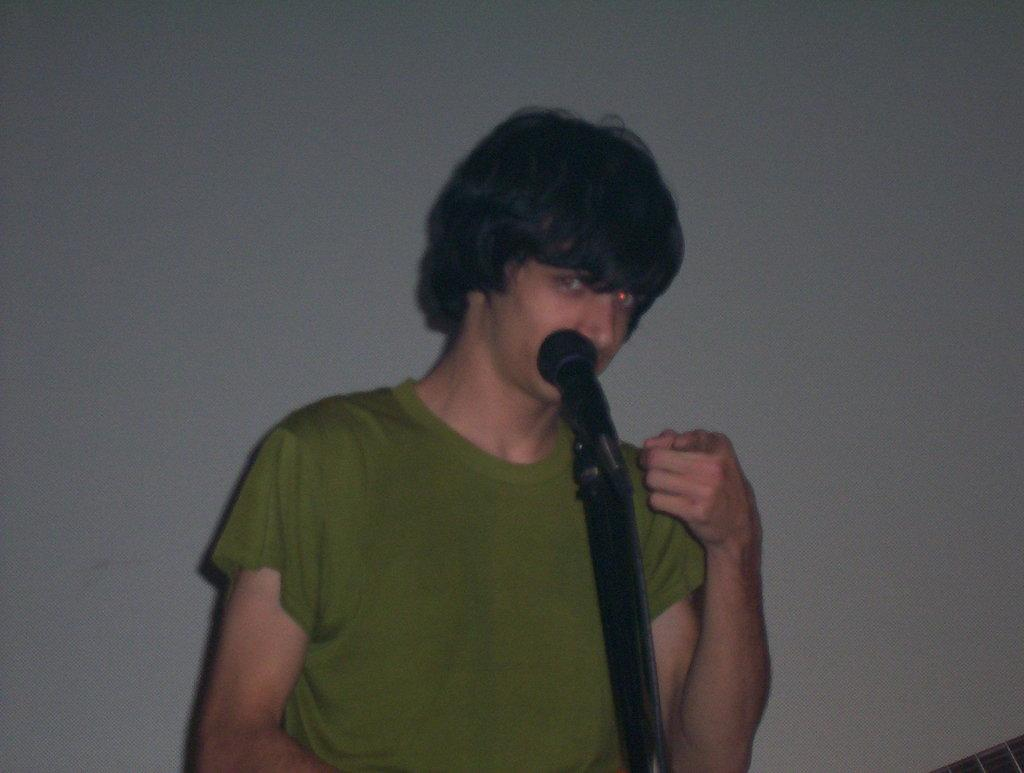Who is the main subject in the image? There is a man in the image. What is the man doing in the image? The man is standing in front of a microphone. What is the man wearing in the image? The man is wearing a green color T-shirt. What can be seen in the background of the image? There is a white color wall in the background of the image. How many girls are present in the image? There are no girls present in the image; it features a man standing in front of a microphone. What type of wood can be seen in the image? There is no wood visible in the image; it features a man standing in front of a microphone with a white color wall in the background. 